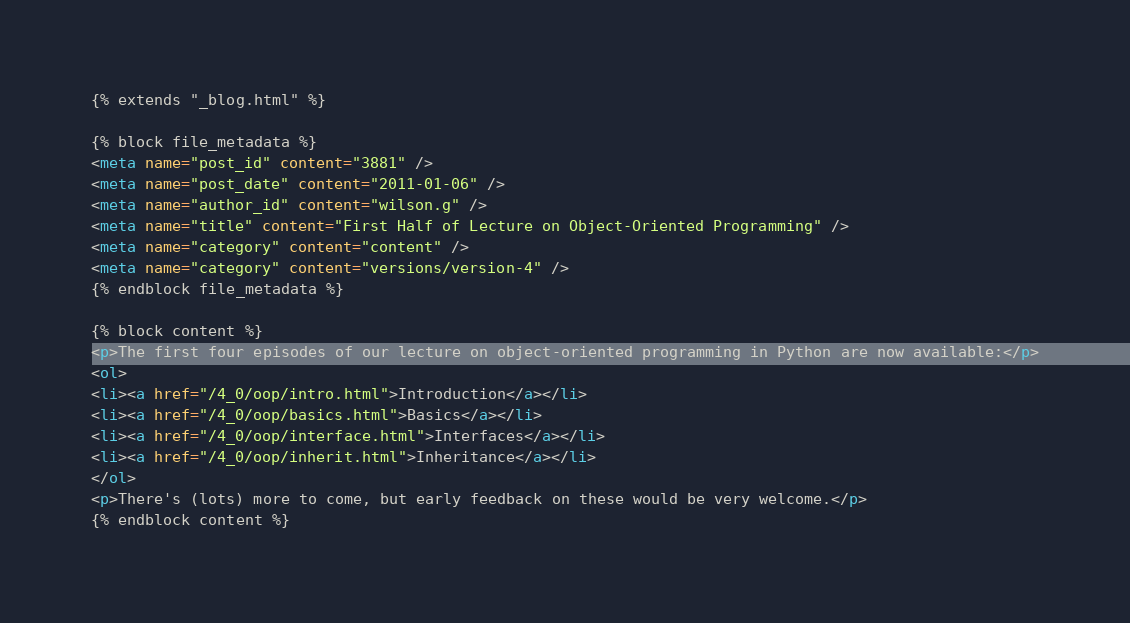<code> <loc_0><loc_0><loc_500><loc_500><_HTML_>{% extends "_blog.html" %}

{% block file_metadata %}
<meta name="post_id" content="3881" />
<meta name="post_date" content="2011-01-06" />
<meta name="author_id" content="wilson.g" />
<meta name="title" content="First Half of Lecture on Object-Oriented Programming" />
<meta name="category" content="content" />
<meta name="category" content="versions/version-4" />
{% endblock file_metadata %}

{% block content %}
<p>The first four episodes of our lecture on object-oriented programming in Python are now available:</p>
<ol>
<li><a href="/4_0/oop/intro.html">Introduction</a></li>
<li><a href="/4_0/oop/basics.html">Basics</a></li>
<li><a href="/4_0/oop/interface.html">Interfaces</a></li>
<li><a href="/4_0/oop/inherit.html">Inheritance</a></li>
</ol>
<p>There's (lots) more to come, but early feedback on these would be very welcome.</p>
{% endblock content %}
</code> 